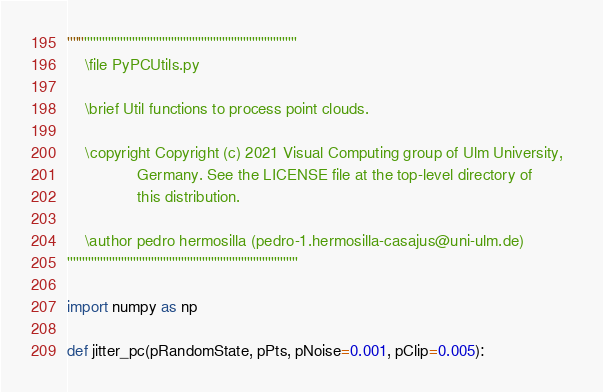<code> <loc_0><loc_0><loc_500><loc_500><_Python_>'''''''''''''''''''''''''''''''''''''''''''''''''''''''''''''''''''''''''''''
    \file PyPCUtils.py

    \brief Util functions to process point clouds.

    \copyright Copyright (c) 2021 Visual Computing group of Ulm University,  
                Germany. See the LICENSE file at the top-level directory of 
                this distribution.

    \author pedro hermosilla (pedro-1.hermosilla-casajus@uni-ulm.de)
'''''''''''''''''''''''''''''''''''''''''''''''''''''''''''''''''''''''''''''

import numpy as np

def jitter_pc(pRandomState, pPts, pNoise=0.001, pClip=0.005):</code> 